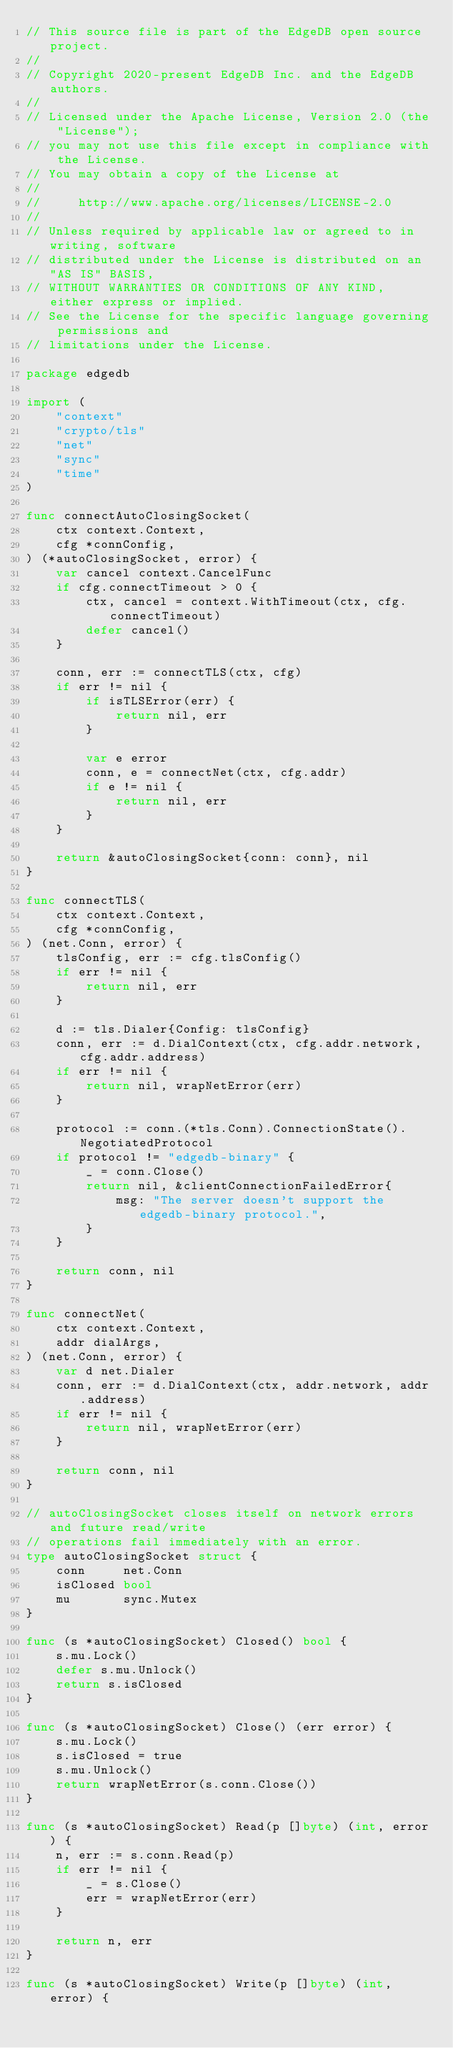<code> <loc_0><loc_0><loc_500><loc_500><_Go_>// This source file is part of the EdgeDB open source project.
//
// Copyright 2020-present EdgeDB Inc. and the EdgeDB authors.
//
// Licensed under the Apache License, Version 2.0 (the "License");
// you may not use this file except in compliance with the License.
// You may obtain a copy of the License at
//
//     http://www.apache.org/licenses/LICENSE-2.0
//
// Unless required by applicable law or agreed to in writing, software
// distributed under the License is distributed on an "AS IS" BASIS,
// WITHOUT WARRANTIES OR CONDITIONS OF ANY KIND, either express or implied.
// See the License for the specific language governing permissions and
// limitations under the License.

package edgedb

import (
	"context"
	"crypto/tls"
	"net"
	"sync"
	"time"
)

func connectAutoClosingSocket(
	ctx context.Context,
	cfg *connConfig,
) (*autoClosingSocket, error) {
	var cancel context.CancelFunc
	if cfg.connectTimeout > 0 {
		ctx, cancel = context.WithTimeout(ctx, cfg.connectTimeout)
		defer cancel()
	}

	conn, err := connectTLS(ctx, cfg)
	if err != nil {
		if isTLSError(err) {
			return nil, err
		}

		var e error
		conn, e = connectNet(ctx, cfg.addr)
		if e != nil {
			return nil, err
		}
	}

	return &autoClosingSocket{conn: conn}, nil
}

func connectTLS(
	ctx context.Context,
	cfg *connConfig,
) (net.Conn, error) {
	tlsConfig, err := cfg.tlsConfig()
	if err != nil {
		return nil, err
	}

	d := tls.Dialer{Config: tlsConfig}
	conn, err := d.DialContext(ctx, cfg.addr.network, cfg.addr.address)
	if err != nil {
		return nil, wrapNetError(err)
	}

	protocol := conn.(*tls.Conn).ConnectionState().NegotiatedProtocol
	if protocol != "edgedb-binary" {
		_ = conn.Close()
		return nil, &clientConnectionFailedError{
			msg: "The server doesn't support the edgedb-binary protocol.",
		}
	}

	return conn, nil
}

func connectNet(
	ctx context.Context,
	addr dialArgs,
) (net.Conn, error) {
	var d net.Dialer
	conn, err := d.DialContext(ctx, addr.network, addr.address)
	if err != nil {
		return nil, wrapNetError(err)
	}

	return conn, nil
}

// autoClosingSocket closes itself on network errors and future read/write
// operations fail immediately with an error.
type autoClosingSocket struct {
	conn     net.Conn
	isClosed bool
	mu       sync.Mutex
}

func (s *autoClosingSocket) Closed() bool {
	s.mu.Lock()
	defer s.mu.Unlock()
	return s.isClosed
}

func (s *autoClosingSocket) Close() (err error) {
	s.mu.Lock()
	s.isClosed = true
	s.mu.Unlock()
	return wrapNetError(s.conn.Close())
}

func (s *autoClosingSocket) Read(p []byte) (int, error) {
	n, err := s.conn.Read(p)
	if err != nil {
		_ = s.Close()
		err = wrapNetError(err)
	}

	return n, err
}

func (s *autoClosingSocket) Write(p []byte) (int, error) {</code> 